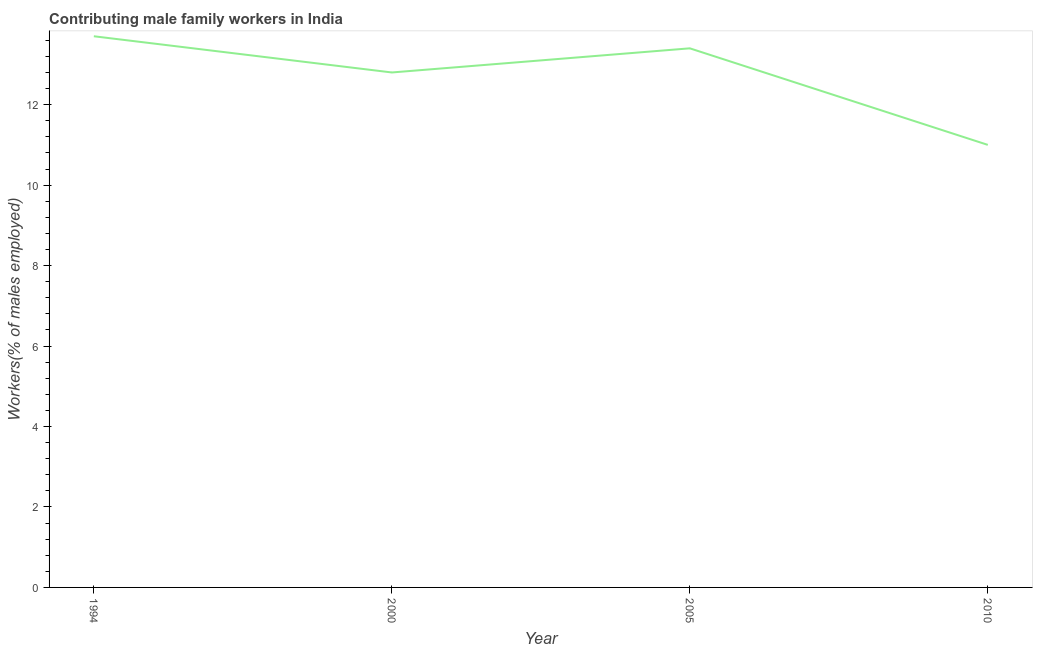What is the contributing male family workers in 2010?
Give a very brief answer. 11. Across all years, what is the maximum contributing male family workers?
Your answer should be very brief. 13.7. In which year was the contributing male family workers maximum?
Your response must be concise. 1994. What is the sum of the contributing male family workers?
Your answer should be compact. 50.9. What is the difference between the contributing male family workers in 1994 and 2005?
Give a very brief answer. 0.3. What is the average contributing male family workers per year?
Your response must be concise. 12.72. What is the median contributing male family workers?
Provide a short and direct response. 13.1. In how many years, is the contributing male family workers greater than 12 %?
Give a very brief answer. 3. What is the ratio of the contributing male family workers in 2000 to that in 2005?
Your answer should be compact. 0.96. Is the contributing male family workers in 2000 less than that in 2005?
Provide a succinct answer. Yes. Is the difference between the contributing male family workers in 1994 and 2000 greater than the difference between any two years?
Provide a short and direct response. No. What is the difference between the highest and the second highest contributing male family workers?
Your answer should be compact. 0.3. Is the sum of the contributing male family workers in 1994 and 2000 greater than the maximum contributing male family workers across all years?
Keep it short and to the point. Yes. What is the difference between the highest and the lowest contributing male family workers?
Keep it short and to the point. 2.7. How many lines are there?
Make the answer very short. 1. What is the difference between two consecutive major ticks on the Y-axis?
Provide a succinct answer. 2. Are the values on the major ticks of Y-axis written in scientific E-notation?
Make the answer very short. No. Does the graph contain any zero values?
Offer a very short reply. No. Does the graph contain grids?
Your answer should be very brief. No. What is the title of the graph?
Your response must be concise. Contributing male family workers in India. What is the label or title of the X-axis?
Make the answer very short. Year. What is the label or title of the Y-axis?
Keep it short and to the point. Workers(% of males employed). What is the Workers(% of males employed) of 1994?
Offer a terse response. 13.7. What is the Workers(% of males employed) in 2000?
Make the answer very short. 12.8. What is the Workers(% of males employed) in 2005?
Ensure brevity in your answer.  13.4. What is the difference between the Workers(% of males employed) in 1994 and 2000?
Make the answer very short. 0.9. What is the difference between the Workers(% of males employed) in 1994 and 2005?
Your answer should be compact. 0.3. What is the difference between the Workers(% of males employed) in 1994 and 2010?
Provide a succinct answer. 2.7. What is the difference between the Workers(% of males employed) in 2005 and 2010?
Offer a very short reply. 2.4. What is the ratio of the Workers(% of males employed) in 1994 to that in 2000?
Give a very brief answer. 1.07. What is the ratio of the Workers(% of males employed) in 1994 to that in 2005?
Your answer should be very brief. 1.02. What is the ratio of the Workers(% of males employed) in 1994 to that in 2010?
Your response must be concise. 1.25. What is the ratio of the Workers(% of males employed) in 2000 to that in 2005?
Your answer should be very brief. 0.95. What is the ratio of the Workers(% of males employed) in 2000 to that in 2010?
Provide a short and direct response. 1.16. What is the ratio of the Workers(% of males employed) in 2005 to that in 2010?
Provide a short and direct response. 1.22. 